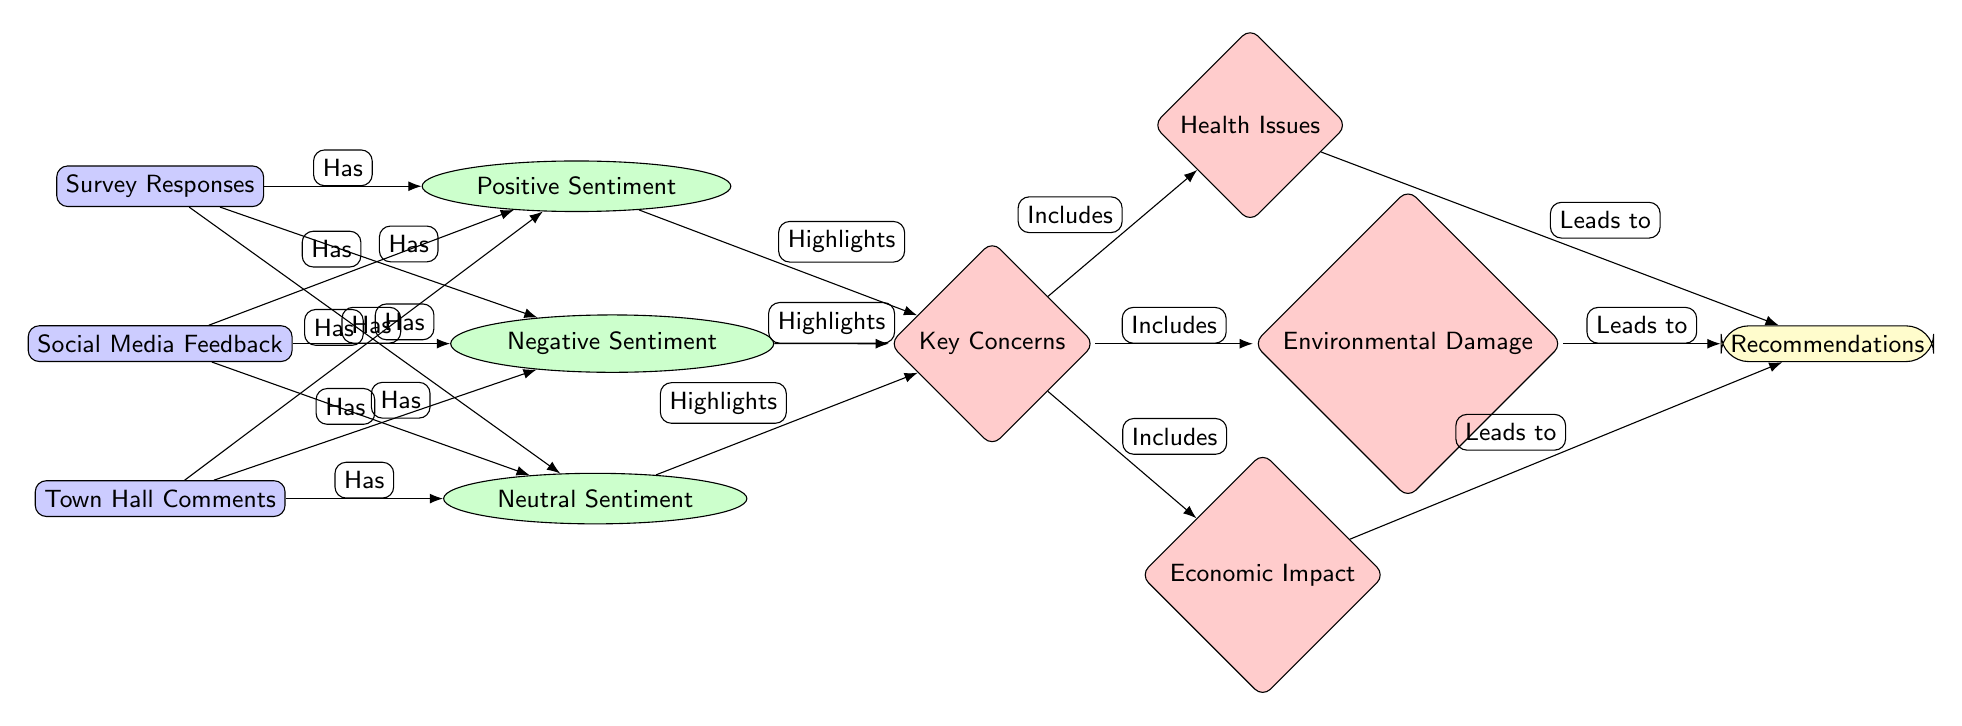What's the total number of data nodes in the diagram? The diagram includes three data nodes: Survey Responses, Social Media Feedback, and Town Hall Comments. Counting these gives a total of three data nodes.
Answer: 3 Which sentiment is associated with Survey Responses? The arrows indicate that Survey Responses is connected to Positive Sentiment, Negative Sentiment, and Neutral Sentiment, meaning it has associations with all three sentiments.
Answer: Positive Sentiment, Negative Sentiment, Neutral Sentiment What are the key concerns highlighted by sentiment? The concerns are connected to both Positive Sentiment and Negative Sentiment via arrows. Therefore, the key concerns highlighted by sentiment include Health Issues, Environmental Damage, and Economic Impact.
Answer: Key Concerns How many specific concerns are listed under Key Concerns? The diagram shows three specific concerns stemming from the Key Concerns node: Health Issues, Environmental Damage, and Economic Impact. Counting these gives a total of three specific concerns.
Answer: 3 What leads to Recommendations in the diagram? The diagram shows that Health Issues, Environmental Damage, and Economic Impact all lead to Recommendations. Thus, these specific concerns are the basis for what leads to the recommendations given in the diagram.
Answer: Health Issues, Environmental Damage, Economic Impact Which sentiment is linked to Town Hall Comments? Town Hall Comments is connected to Positive Sentiment, Negative Sentiment, and Neutral Sentiment. The connections indicate that all three sentiments are linked to Town Hall Comments.
Answer: Positive Sentiment, Negative Sentiment, Neutral Sentiment What type of diagram is this that focuses on social opinions? This diagram displays the sentiments and opinions of residents gathered from various sources, illustrating how public opinion is analyzed through sentiment. Therefore, it can be classified as a Social Science Diagram.
Answer: Social Science Diagram Which concern is directly linked to Health Issues? The flow indicates that Health Issues is one of the specific concerns derived from Key Concerns, which subsequently leads to Recommendations. Thus, Health Issues is directly associated with the recommendations made.
Answer: Recommendations 